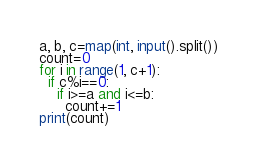Convert code to text. <code><loc_0><loc_0><loc_500><loc_500><_Python_>a, b, c=map(int, input().split())
count=0
for i in range(1, c+1):
  if c%i==0:
    if i>=a and i<=b:
      count+=1
print(count)
</code> 